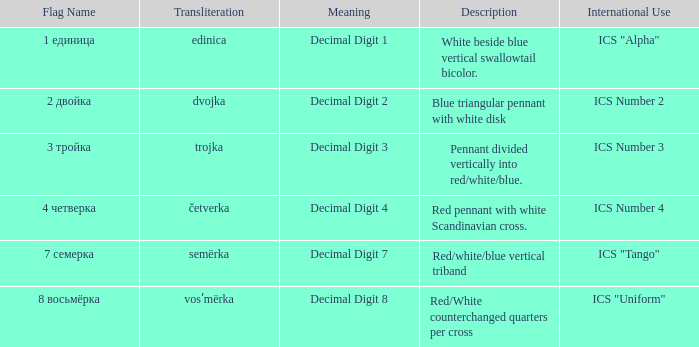What are the interpretations of the flag known as "semërka" in transliteration? Decimal Digit 7. Could you parse the entire table? {'header': ['Flag Name', 'Transliteration', 'Meaning', 'Description', 'International Use'], 'rows': [['1 единица', 'edinica', 'Decimal Digit 1', 'White beside blue vertical swallowtail bicolor.', 'ICS "Alpha"'], ['2 двойка', 'dvojka', 'Decimal Digit 2', 'Blue triangular pennant with white disk', 'ICS Number 2'], ['3 тройка', 'trojka', 'Decimal Digit 3', 'Pennant divided vertically into red/white/blue.', 'ICS Number 3'], ['4 четверка', 'četverka', 'Decimal Digit 4', 'Red pennant with white Scandinavian cross.', 'ICS Number 4'], ['7 семерка', 'semërka', 'Decimal Digit 7', 'Red/white/blue vertical triband', 'ICS "Tango"'], ['8 восьмёрка', 'vosʹmërka', 'Decimal Digit 8', 'Red/White counterchanged quarters per cross', 'ICS "Uniform"']]} 